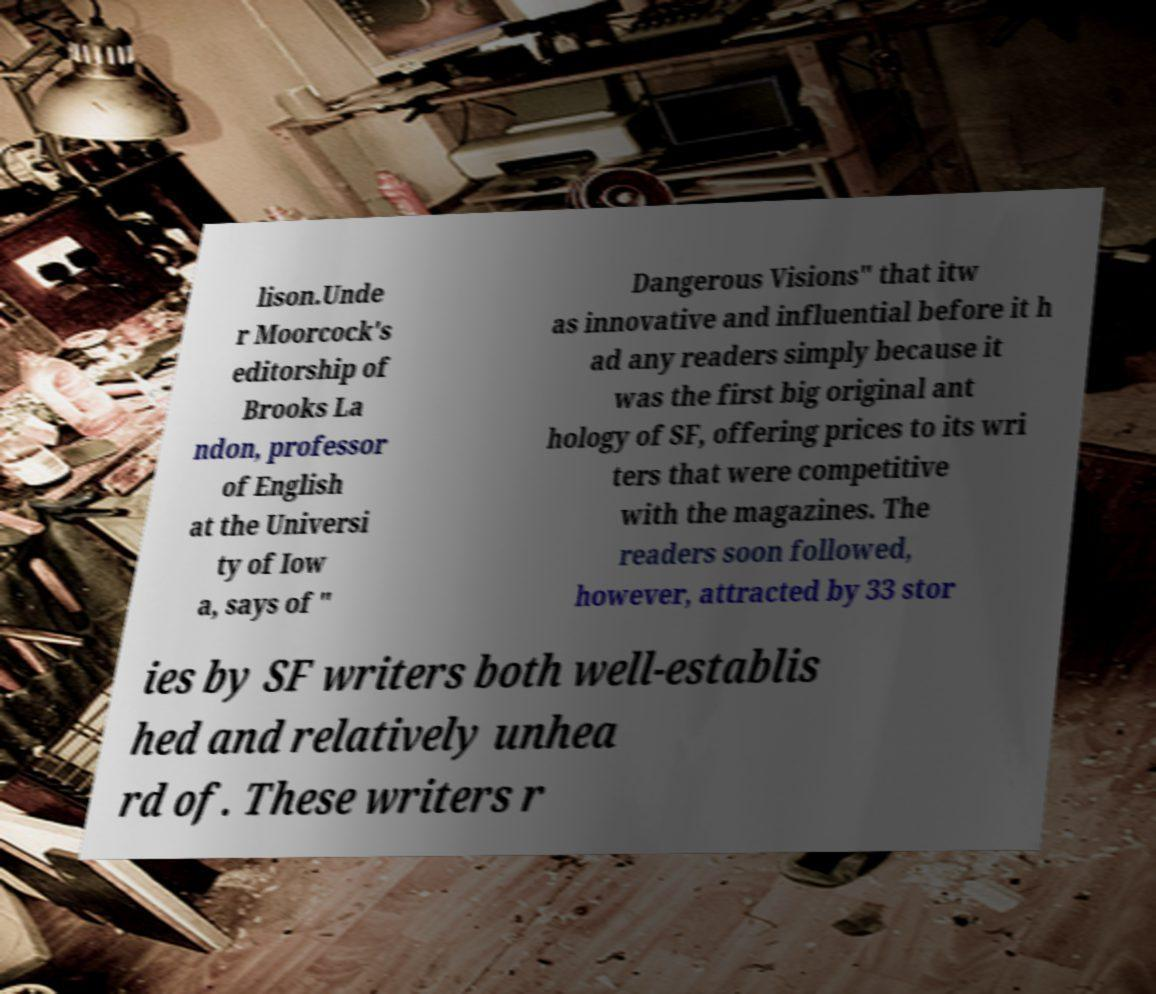Please read and relay the text visible in this image. What does it say? lison.Unde r Moorcock's editorship of Brooks La ndon, professor of English at the Universi ty of Iow a, says of " Dangerous Visions" that itw as innovative and influential before it h ad any readers simply because it was the first big original ant hology of SF, offering prices to its wri ters that were competitive with the magazines. The readers soon followed, however, attracted by 33 stor ies by SF writers both well-establis hed and relatively unhea rd of. These writers r 